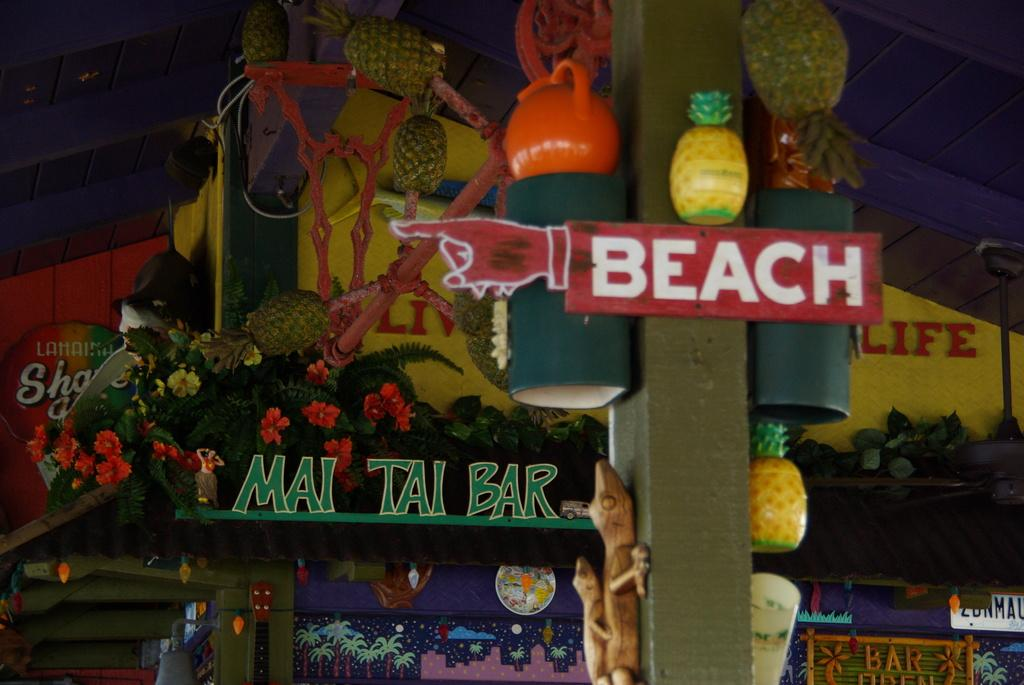<image>
Share a concise interpretation of the image provided. A green sign reads "Mai Tai Bar" below a red Beach sign. 